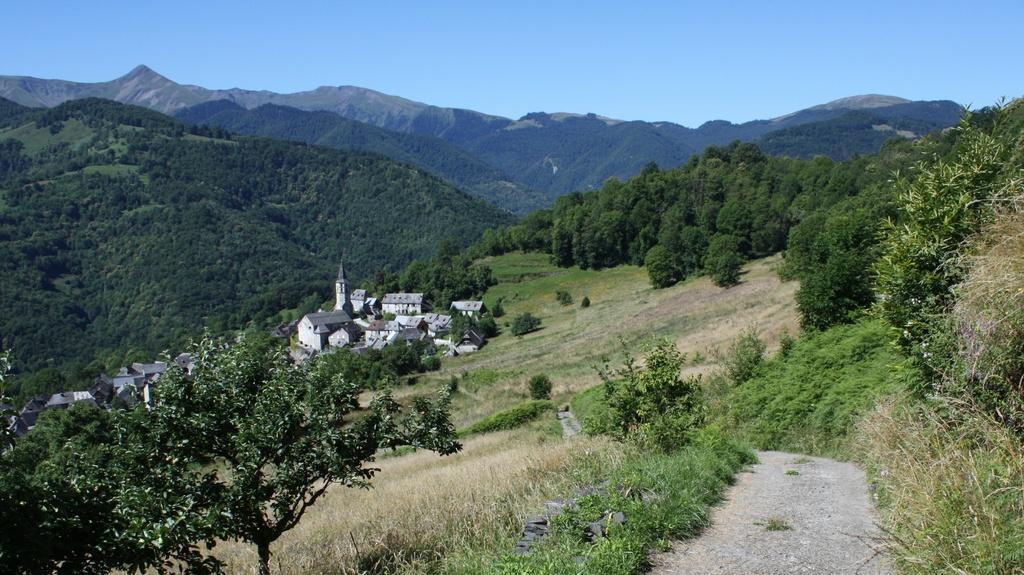Can you describe this image briefly? In this picture there are houses on the left side of the image and there is greenery around the area of the image. 